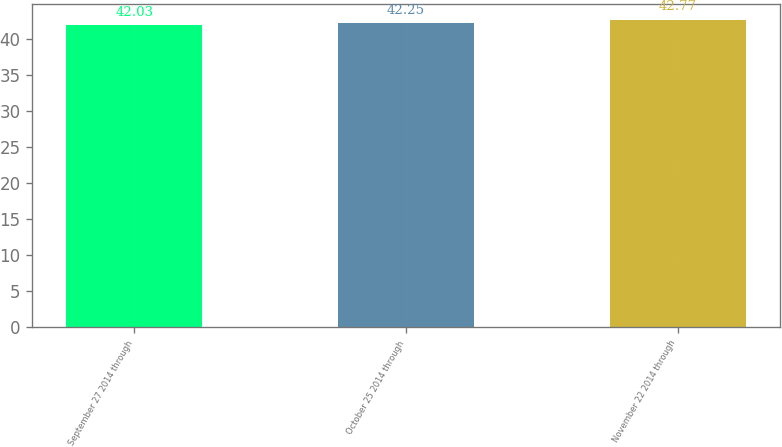<chart> <loc_0><loc_0><loc_500><loc_500><bar_chart><fcel>September 27 2014 through<fcel>October 25 2014 through<fcel>November 22 2014 through<nl><fcel>42.03<fcel>42.25<fcel>42.77<nl></chart> 